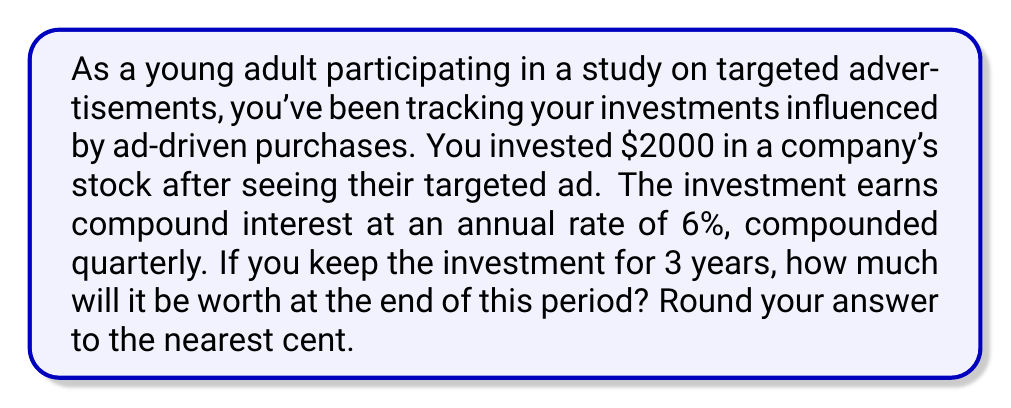Give your solution to this math problem. To solve this problem, we'll use the compound interest formula:

$$A = P(1 + \frac{r}{n})^{nt}$$

Where:
$A$ = final amount
$P$ = principal (initial investment)
$r$ = annual interest rate (in decimal form)
$n$ = number of times interest is compounded per year
$t$ = number of years

Given:
$P = \$2000$
$r = 6\% = 0.06$
$n = 4$ (compounded quarterly)
$t = 3$ years

Let's substitute these values into the formula:

$$A = 2000(1 + \frac{0.06}{4})^{4 \times 3}$$

$$A = 2000(1 + 0.015)^{12}$$

$$A = 2000(1.015)^{12}$$

Now, let's calculate this step by step:

1. Calculate $(1.015)^{12}$:
   $(1.015)^{12} \approx 1.1956$

2. Multiply by the principal:
   $2000 \times 1.1956 = 2391.20$

Therefore, after 3 years, the investment will be worth $2391.20.
Answer: $2391.20 